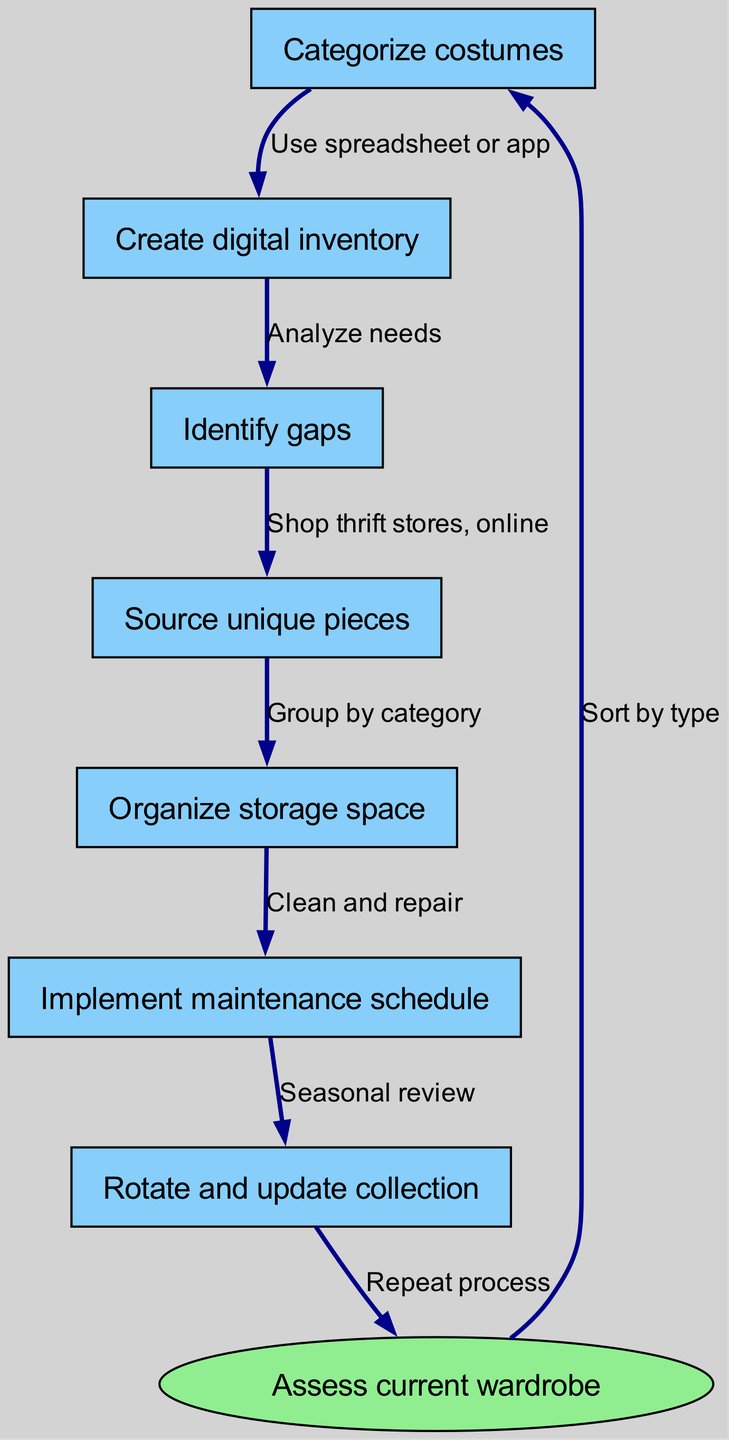What is the starting point of this flow chart? The initial step in the flow chart is labeled as "Assess current wardrobe," which represents the beginning of the process for organizing and maintaining a costume wardrobe.
Answer: Assess current wardrobe How many nodes are in the diagram? The diagram contains a total of eight nodes, including the starting node and the seven subsequent steps in the flow chart.
Answer: 8 What comes after "Categorize costumes"? The next step after "Categorize costumes" is "Create digital inventory," indicating that the process continues with the creation of an inventory after categorization.
Answer: Create digital inventory Which node is linked to "Source unique pieces"? The node that leads to "Source unique pieces" is "Identify gaps," suggesting that after gaps have been identified in the wardrobe, unique pieces should be sourced.
Answer: Identify gaps What is the final step in the process? The last step in the flow chart is "Assess current wardrobe," which indicates a return to review the initial inventory and enjoy a cyclical process of maintaining the wardrobe.
Answer: Assess current wardrobe How many edges are in the diagram? There are seven edges in the flow chart, representing the different connections and relationships between the various nodes as one progresses through the steps.
Answer: 7 What is the relationship between "Implement maintenance schedule" and "Rotate and update collection"? The relationship is such that after implementing a maintenance schedule, which includes cleaning and repairing, the next step is to "Rotate and update collection," which involves reviewing the wardrobe seasonally.
Answer: Seasonal review What action should be taken after identifying gaps? After identifying gaps in the wardrobe, the action to take is to "Source unique pieces," which means seeking out new items to fill those gaps.
Answer: Source unique pieces 